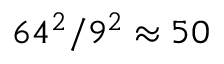Convert formula to latex. <formula><loc_0><loc_0><loc_500><loc_500>6 4 ^ { 2 } / 9 ^ { 2 } \approx 5 0</formula> 